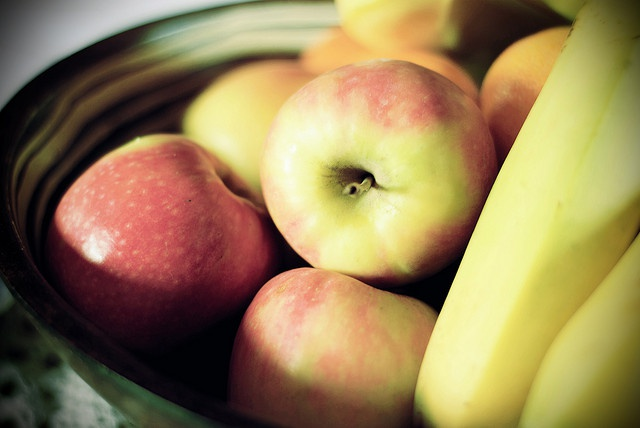Describe the objects in this image and their specific colors. I can see bowl in black, khaki, and tan tones, apple in black, khaki, tan, and maroon tones, banana in black, khaki, and olive tones, banana in black, tan, khaki, and olive tones, and apple in black, khaki, and tan tones in this image. 